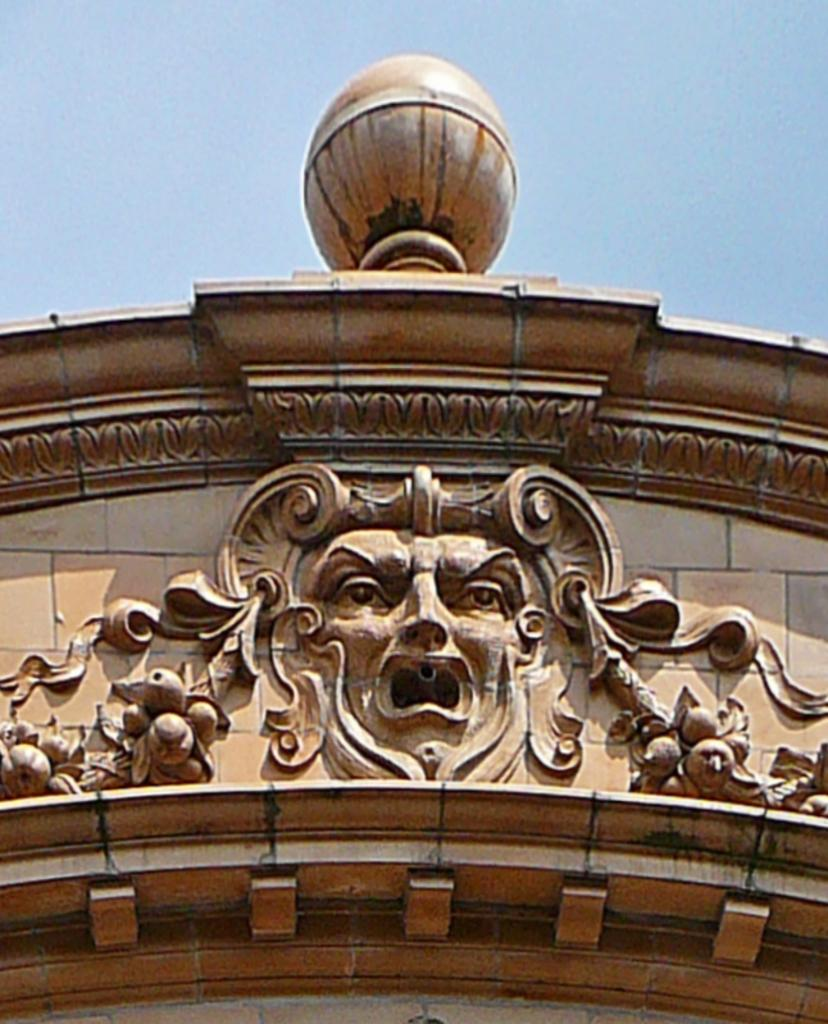What type of structure is present in the image? There is a building in the image. Are there any specific details on the building? Yes, there is a carving on the building. What is the color of the sky in the image? The sky is blue in color. Can you see any bees buzzing around the carving on the building? There is no mention of bees in the image, so we cannot determine if they are present or not. What type of flesh can be seen on the carving of the building? There is no flesh present on the carving of the building, as it is a carving on a building and not a living organism. 